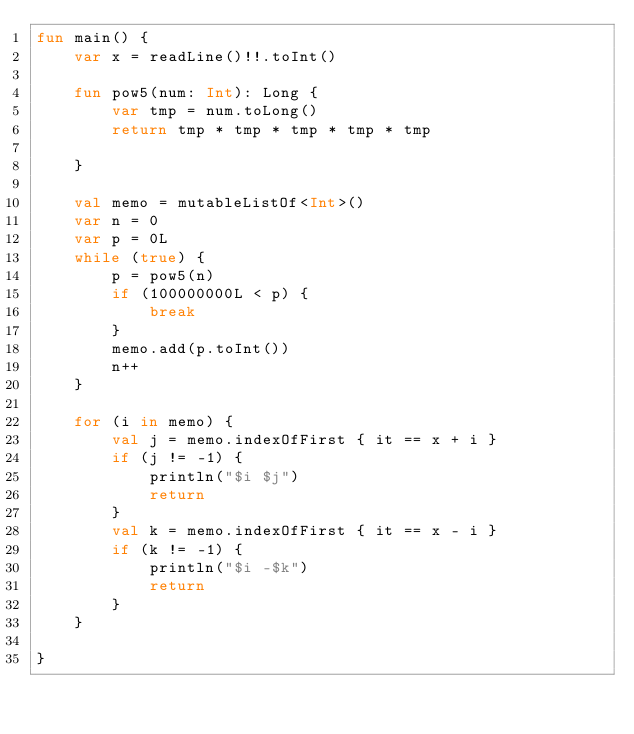<code> <loc_0><loc_0><loc_500><loc_500><_Kotlin_>fun main() {
    var x = readLine()!!.toInt()

    fun pow5(num: Int): Long {
        var tmp = num.toLong()
        return tmp * tmp * tmp * tmp * tmp

    }

    val memo = mutableListOf<Int>()
    var n = 0
    var p = 0L
    while (true) {
        p = pow5(n)
        if (100000000L < p) {
            break
        }
        memo.add(p.toInt())
        n++
    }

    for (i in memo) {
        val j = memo.indexOfFirst { it == x + i }
        if (j != -1) {
            println("$i $j")
            return
        }
        val k = memo.indexOfFirst { it == x - i }
        if (k != -1) {
            println("$i -$k")
            return
        }
    }

}



</code> 